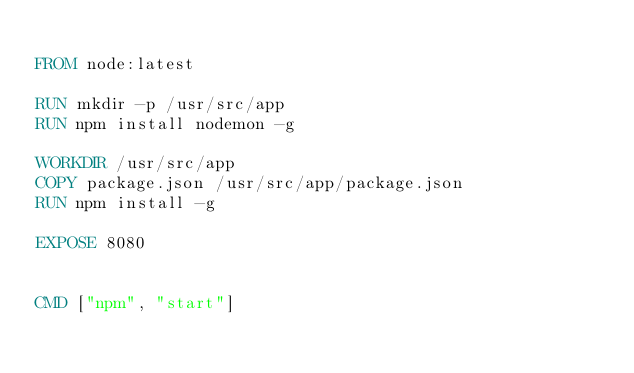<code> <loc_0><loc_0><loc_500><loc_500><_Dockerfile_>
FROM node:latest

RUN mkdir -p /usr/src/app
RUN npm install nodemon -g

WORKDIR /usr/src/app
COPY package.json /usr/src/app/package.json
RUN npm install -g

EXPOSE 8080


CMD ["npm", "start"]</code> 